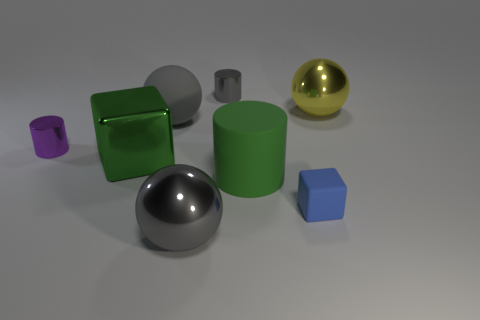Add 2 metallic cylinders. How many objects exist? 10 Subtract all spheres. How many objects are left? 5 Subtract 0 yellow cubes. How many objects are left? 8 Subtract all big green rubber spheres. Subtract all big green matte things. How many objects are left? 7 Add 7 gray rubber spheres. How many gray rubber spheres are left? 8 Add 3 green objects. How many green objects exist? 5 